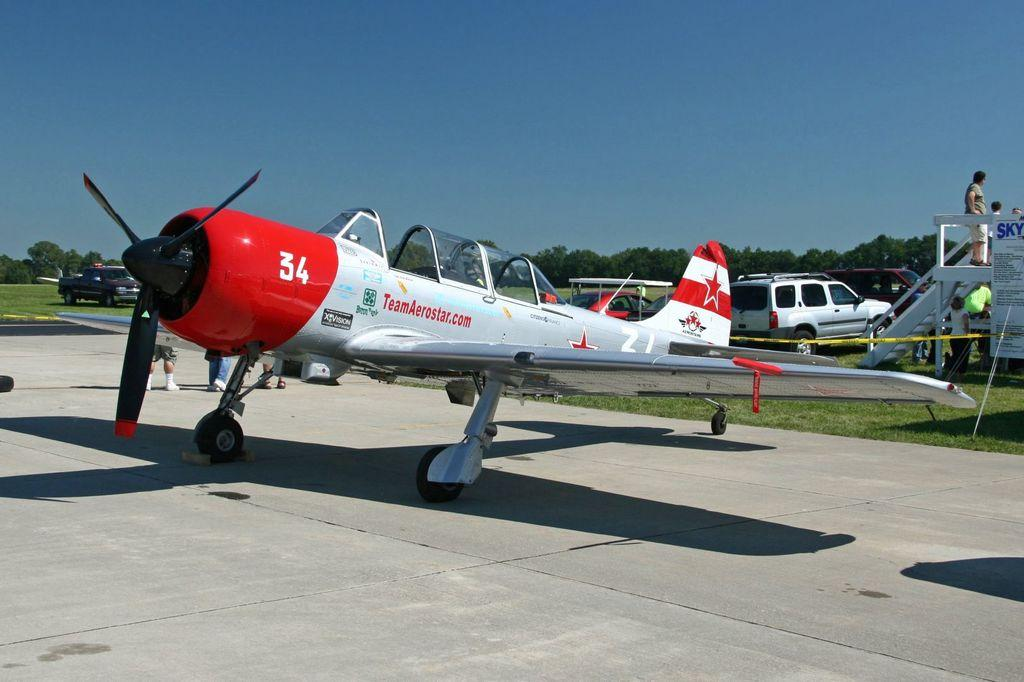<image>
Give a short and clear explanation of the subsequent image. A number 34 is on the front of a red and white airplane. 